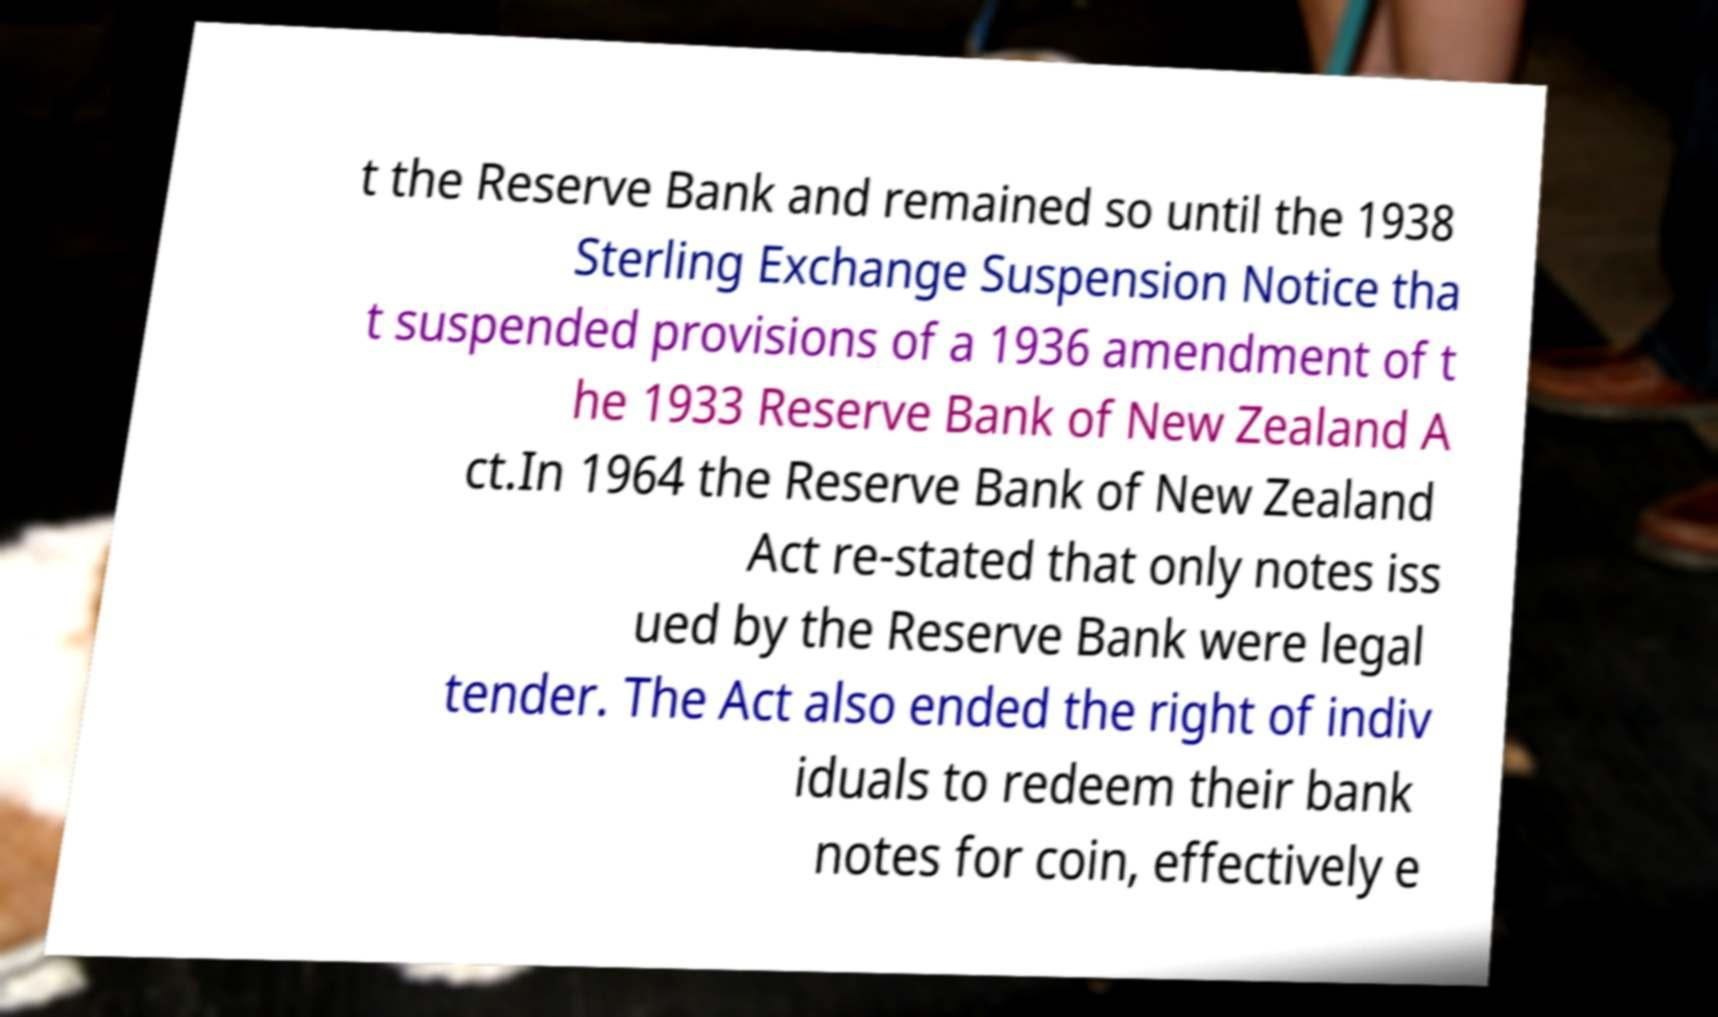I need the written content from this picture converted into text. Can you do that? t the Reserve Bank and remained so until the 1938 Sterling Exchange Suspension Notice tha t suspended provisions of a 1936 amendment of t he 1933 Reserve Bank of New Zealand A ct.In 1964 the Reserve Bank of New Zealand Act re-stated that only notes iss ued by the Reserve Bank were legal tender. The Act also ended the right of indiv iduals to redeem their bank notes for coin, effectively e 